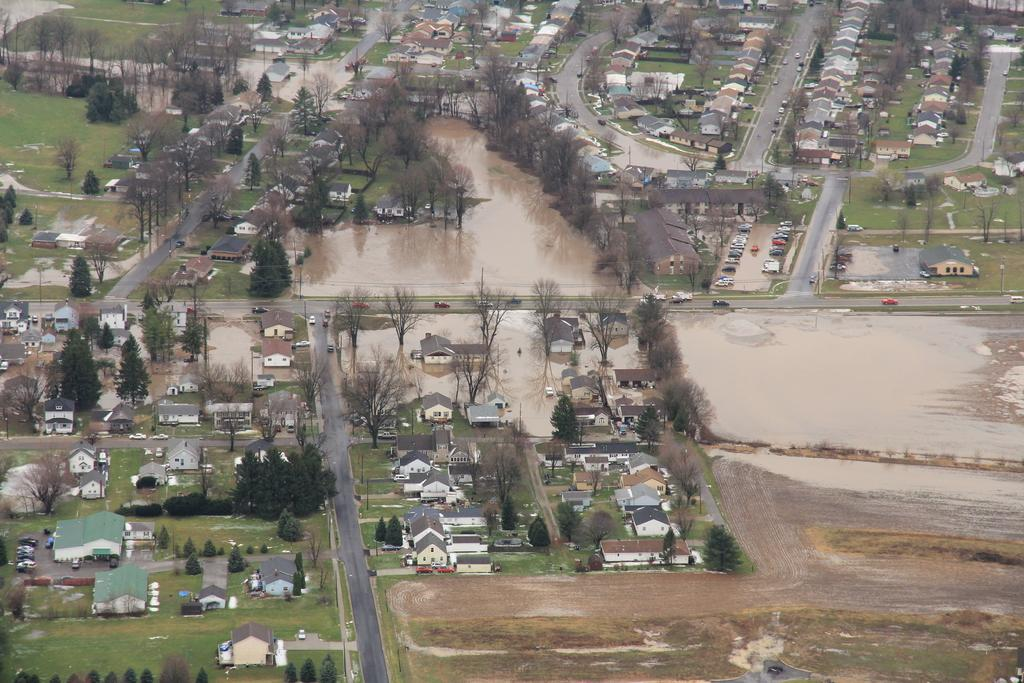What type of structures can be seen in the image? There are houses in the image. What connects the houses and other areas in the image? There are roads in the image. What natural element is visible between the houses? There is water visible between the houses. What is moving on the roads in the image? There are vehicles moving on the roads. What type of vegetation can be seen in the image? There are trees in the image. Can you tell me how many coasts are visible in the image? There is no coast visible in the image; it features houses, roads, water, vehicles, and trees. What type of liquid can be seen flowing between the houses in the image? There is no liquid flowing between the houses in the image; it is a body of still water. 